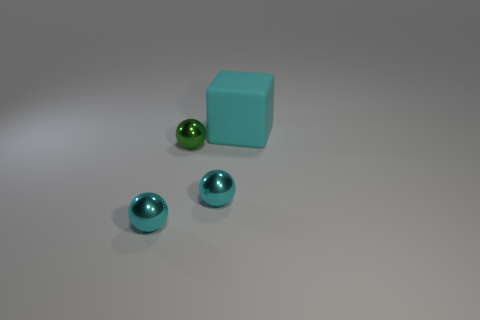Add 4 big red cubes. How many objects exist? 8 Subtract all spheres. How many objects are left? 1 Add 1 big cyan blocks. How many big cyan blocks are left? 2 Add 3 small cyan shiny things. How many small cyan shiny things exist? 5 Subtract 0 gray balls. How many objects are left? 4 Subtract all large cyan objects. Subtract all rubber cubes. How many objects are left? 2 